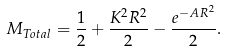<formula> <loc_0><loc_0><loc_500><loc_500>M _ { T o t a l } = \frac { 1 } { 2 } + \frac { K ^ { 2 } R ^ { 2 } } { 2 } - \frac { e ^ { - A R ^ { 2 } } } { 2 } .</formula> 